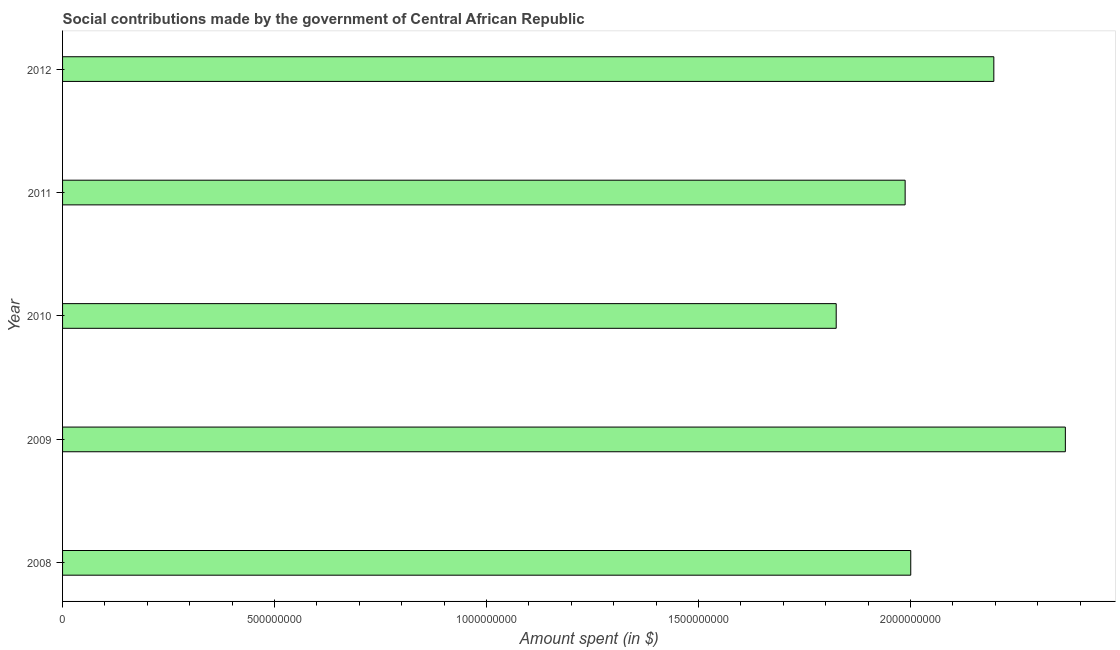What is the title of the graph?
Provide a succinct answer. Social contributions made by the government of Central African Republic. What is the label or title of the X-axis?
Ensure brevity in your answer.  Amount spent (in $). What is the label or title of the Y-axis?
Ensure brevity in your answer.  Year. What is the amount spent in making social contributions in 2009?
Your response must be concise. 2.37e+09. Across all years, what is the maximum amount spent in making social contributions?
Give a very brief answer. 2.37e+09. Across all years, what is the minimum amount spent in making social contributions?
Provide a succinct answer. 1.82e+09. In which year was the amount spent in making social contributions maximum?
Offer a terse response. 2009. In which year was the amount spent in making social contributions minimum?
Your response must be concise. 2010. What is the sum of the amount spent in making social contributions?
Keep it short and to the point. 1.04e+1. What is the difference between the amount spent in making social contributions in 2008 and 2011?
Make the answer very short. 1.32e+07. What is the average amount spent in making social contributions per year?
Your answer should be compact. 2.08e+09. What is the median amount spent in making social contributions?
Your response must be concise. 2.00e+09. What is the ratio of the amount spent in making social contributions in 2008 to that in 2010?
Your response must be concise. 1.1. Is the amount spent in making social contributions in 2010 less than that in 2011?
Give a very brief answer. Yes. Is the difference between the amount spent in making social contributions in 2008 and 2010 greater than the difference between any two years?
Provide a succinct answer. No. What is the difference between the highest and the second highest amount spent in making social contributions?
Keep it short and to the point. 1.69e+08. Is the sum of the amount spent in making social contributions in 2008 and 2011 greater than the maximum amount spent in making social contributions across all years?
Make the answer very short. Yes. What is the difference between the highest and the lowest amount spent in making social contributions?
Your answer should be very brief. 5.41e+08. In how many years, is the amount spent in making social contributions greater than the average amount spent in making social contributions taken over all years?
Provide a short and direct response. 2. Are the values on the major ticks of X-axis written in scientific E-notation?
Provide a succinct answer. No. What is the Amount spent (in $) of 2008?
Make the answer very short. 2.00e+09. What is the Amount spent (in $) in 2009?
Offer a terse response. 2.37e+09. What is the Amount spent (in $) of 2010?
Ensure brevity in your answer.  1.82e+09. What is the Amount spent (in $) in 2011?
Keep it short and to the point. 1.99e+09. What is the Amount spent (in $) of 2012?
Your answer should be compact. 2.20e+09. What is the difference between the Amount spent (in $) in 2008 and 2009?
Give a very brief answer. -3.65e+08. What is the difference between the Amount spent (in $) in 2008 and 2010?
Offer a very short reply. 1.76e+08. What is the difference between the Amount spent (in $) in 2008 and 2011?
Give a very brief answer. 1.32e+07. What is the difference between the Amount spent (in $) in 2008 and 2012?
Give a very brief answer. -1.96e+08. What is the difference between the Amount spent (in $) in 2009 and 2010?
Make the answer very short. 5.41e+08. What is the difference between the Amount spent (in $) in 2009 and 2011?
Provide a succinct answer. 3.78e+08. What is the difference between the Amount spent (in $) in 2009 and 2012?
Your answer should be very brief. 1.69e+08. What is the difference between the Amount spent (in $) in 2010 and 2011?
Your response must be concise. -1.63e+08. What is the difference between the Amount spent (in $) in 2010 and 2012?
Offer a terse response. -3.72e+08. What is the difference between the Amount spent (in $) in 2011 and 2012?
Provide a short and direct response. -2.09e+08. What is the ratio of the Amount spent (in $) in 2008 to that in 2009?
Your response must be concise. 0.85. What is the ratio of the Amount spent (in $) in 2008 to that in 2010?
Offer a very short reply. 1.1. What is the ratio of the Amount spent (in $) in 2008 to that in 2011?
Offer a terse response. 1.01. What is the ratio of the Amount spent (in $) in 2008 to that in 2012?
Keep it short and to the point. 0.91. What is the ratio of the Amount spent (in $) in 2009 to that in 2010?
Provide a succinct answer. 1.3. What is the ratio of the Amount spent (in $) in 2009 to that in 2011?
Ensure brevity in your answer.  1.19. What is the ratio of the Amount spent (in $) in 2009 to that in 2012?
Make the answer very short. 1.08. What is the ratio of the Amount spent (in $) in 2010 to that in 2011?
Provide a succinct answer. 0.92. What is the ratio of the Amount spent (in $) in 2010 to that in 2012?
Keep it short and to the point. 0.83. What is the ratio of the Amount spent (in $) in 2011 to that in 2012?
Your answer should be compact. 0.91. 